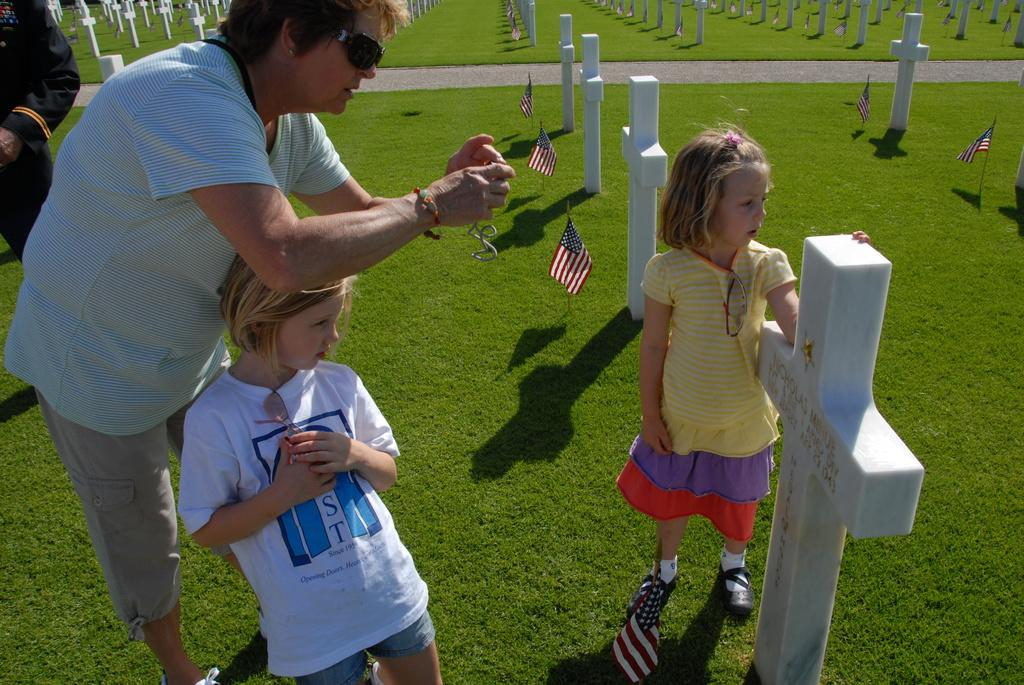What is the setting of the image? The image depicts a graveyard. How many kids are present in the image? There are two kids standing in the image. What are the kids wearing? The kids are wearing clothes. What can be seen in the middle of the image? There are flags in the middle of the image. How many persons wearing clothes can be seen in the image? There are two persons wearing clothes in the image. What type of glove is the parent wearing in the image? There is no parent or glove present in the image. What type of school is visible in the background of the image? There is no school visible in the image; it depicts a graveyard. 